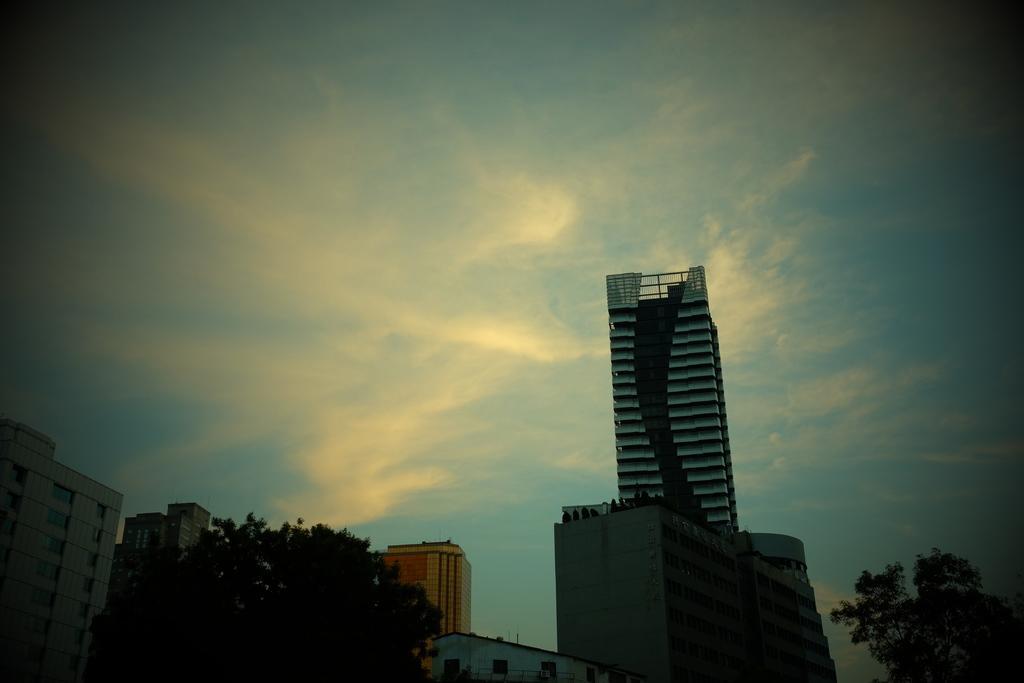Please provide a concise description of this image. In this picture there are buildings at the bottom side of the image and there are trees on the right and left side of the image, there is sky at the top side of the image. 